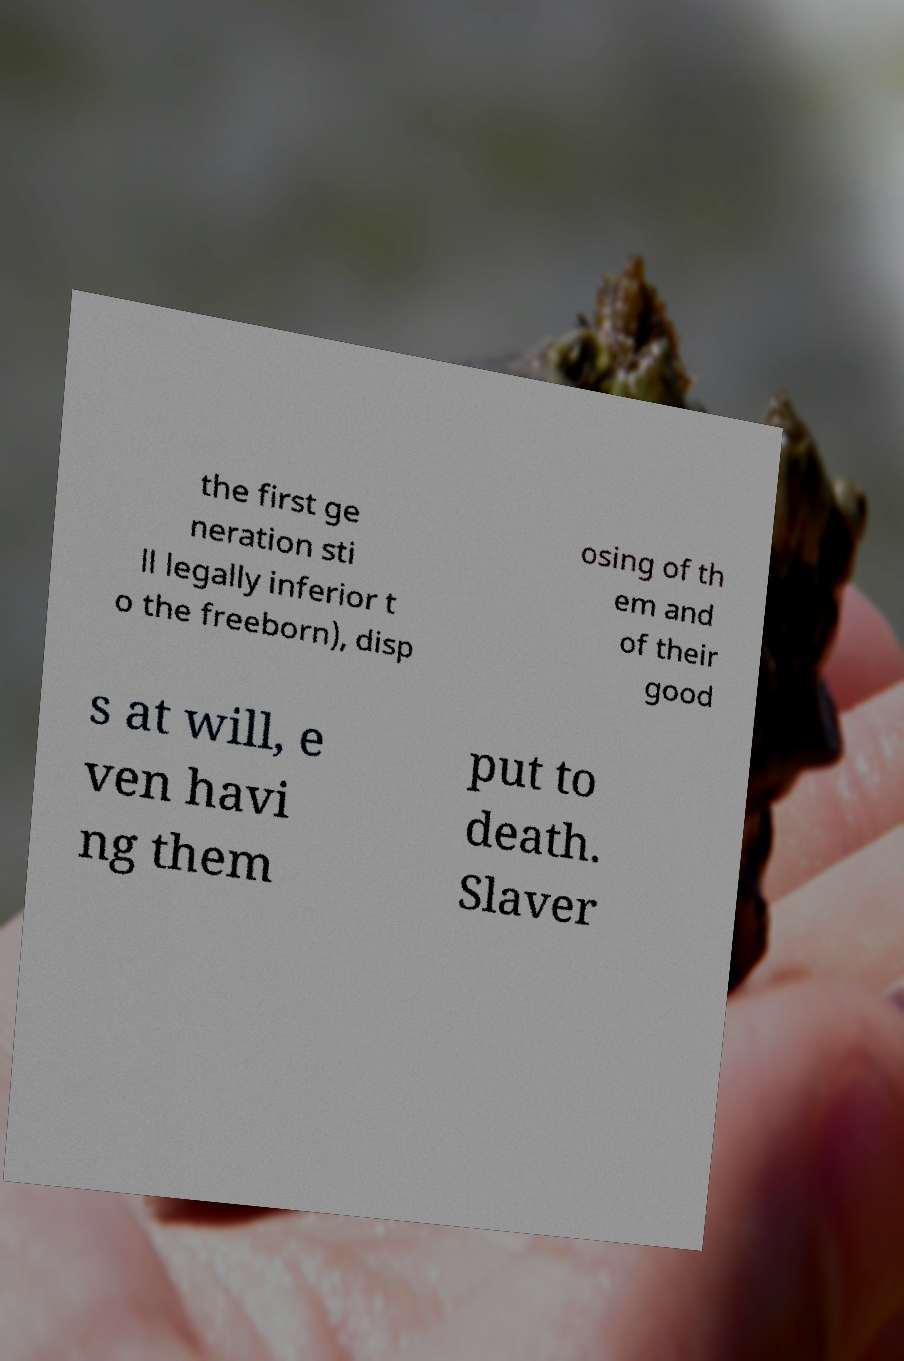What messages or text are displayed in this image? I need them in a readable, typed format. the first ge neration sti ll legally inferior t o the freeborn), disp osing of th em and of their good s at will, e ven havi ng them put to death. Slaver 